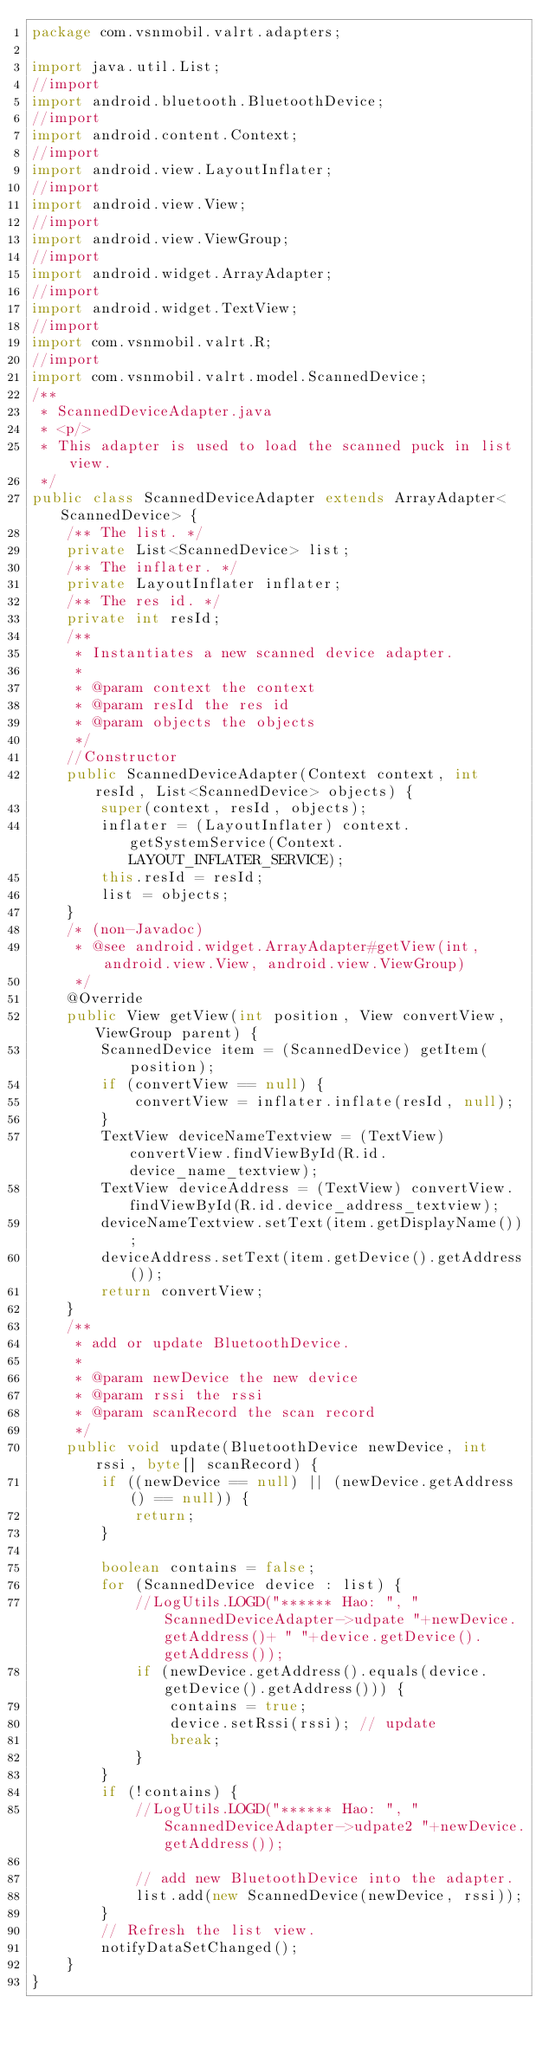<code> <loc_0><loc_0><loc_500><loc_500><_Java_>package com.vsnmobil.valrt.adapters;

import java.util.List;
//import
import android.bluetooth.BluetoothDevice;
//import
import android.content.Context;
//import
import android.view.LayoutInflater;
//import
import android.view.View;
//import
import android.view.ViewGroup;
//import
import android.widget.ArrayAdapter;
//import
import android.widget.TextView;
//import
import com.vsnmobil.valrt.R;
//import
import com.vsnmobil.valrt.model.ScannedDevice;
/**
 * ScannedDeviceAdapter.java
 * <p/>
 * This adapter is used to load the scanned puck in list view.
 */
public class ScannedDeviceAdapter extends ArrayAdapter<ScannedDevice> {
    /** The list. */
    private List<ScannedDevice> list;
    /** The inflater. */
    private LayoutInflater inflater;
    /** The res id. */
    private int resId;
    /**
     * Instantiates a new scanned device adapter.
     *
     * @param context the context
     * @param resId the res id
     * @param objects the objects
     */
    //Constructor
    public ScannedDeviceAdapter(Context context, int resId, List<ScannedDevice> objects) {
        super(context, resId, objects);
        inflater = (LayoutInflater) context.getSystemService(Context.LAYOUT_INFLATER_SERVICE);
        this.resId = resId;
        list = objects;
    }
    /* (non-Javadoc)
     * @see android.widget.ArrayAdapter#getView(int, android.view.View, android.view.ViewGroup)
     */
    @Override
    public View getView(int position, View convertView, ViewGroup parent) {
        ScannedDevice item = (ScannedDevice) getItem(position);
        if (convertView == null) {
            convertView = inflater.inflate(resId, null);
        }
        TextView deviceNameTextview = (TextView) convertView.findViewById(R.id.device_name_textview);
        TextView deviceAddress = (TextView) convertView.findViewById(R.id.device_address_textview);
        deviceNameTextview.setText(item.getDisplayName());
        deviceAddress.setText(item.getDevice().getAddress());
        return convertView;
    }
    /**
     * add or update BluetoothDevice.
     *
     * @param newDevice the new device
     * @param rssi the rssi
     * @param scanRecord the scan record
     */
    public void update(BluetoothDevice newDevice, int rssi, byte[] scanRecord) {
        if ((newDevice == null) || (newDevice.getAddress() == null)) {
            return;
        }

        boolean contains = false;
        for (ScannedDevice device : list) {
            //LogUtils.LOGD("****** Hao: ", "ScannedDeviceAdapter->udpate "+newDevice.getAddress()+ " "+device.getDevice().getAddress());
            if (newDevice.getAddress().equals(device.getDevice().getAddress())) {
                contains = true;
                device.setRssi(rssi); // update
                break;
            }
        }
        if (!contains) {
            //LogUtils.LOGD("****** Hao: ", "ScannedDeviceAdapter->udpate2 "+newDevice.getAddress());

            // add new BluetoothDevice into the adapter.
            list.add(new ScannedDevice(newDevice, rssi));
        }
        // Refresh the list view.
        notifyDataSetChanged();
    }
}
</code> 